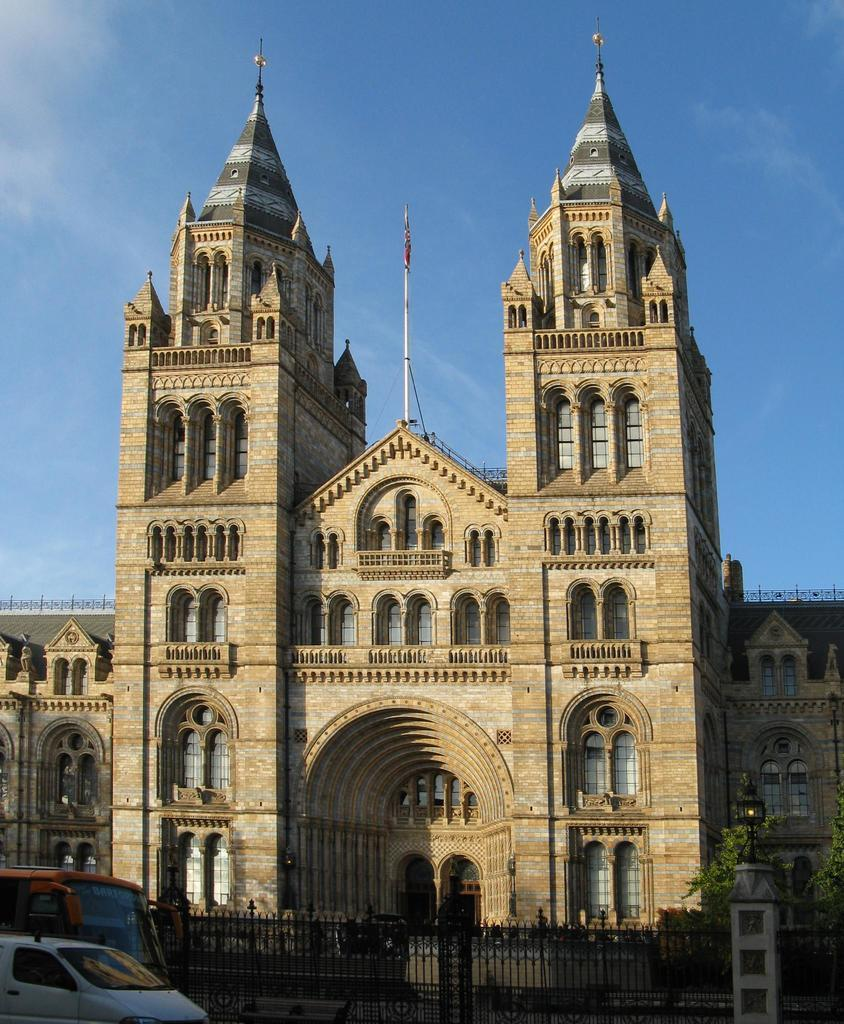What type of objects can be seen in the image? There are vehicles in the image. What structure is present in the image? There is a gate in the image. What type of vegetation is on the right side of the image? There are trees on the right side of the image. What is located at the back of the image? There is a building at the back of the image. What is visible at the top of the image? The sky is visible at the top of the image. How many legs can be seen on the field in the image? There is no field present in the image, and therefore no legs can be seen on it. What type of club is associated with the vehicles in the image? There is no club mentioned or depicted in the image; it only features vehicles, a gate, trees, a building, and the sky. 